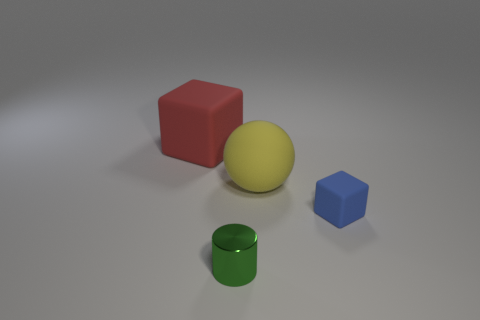Add 2 blue matte balls. How many objects exist? 6 Subtract all balls. How many objects are left? 3 Subtract all tiny blue cubes. Subtract all blue blocks. How many objects are left? 2 Add 3 matte things. How many matte things are left? 6 Add 4 small rubber things. How many small rubber things exist? 5 Subtract 0 brown cylinders. How many objects are left? 4 